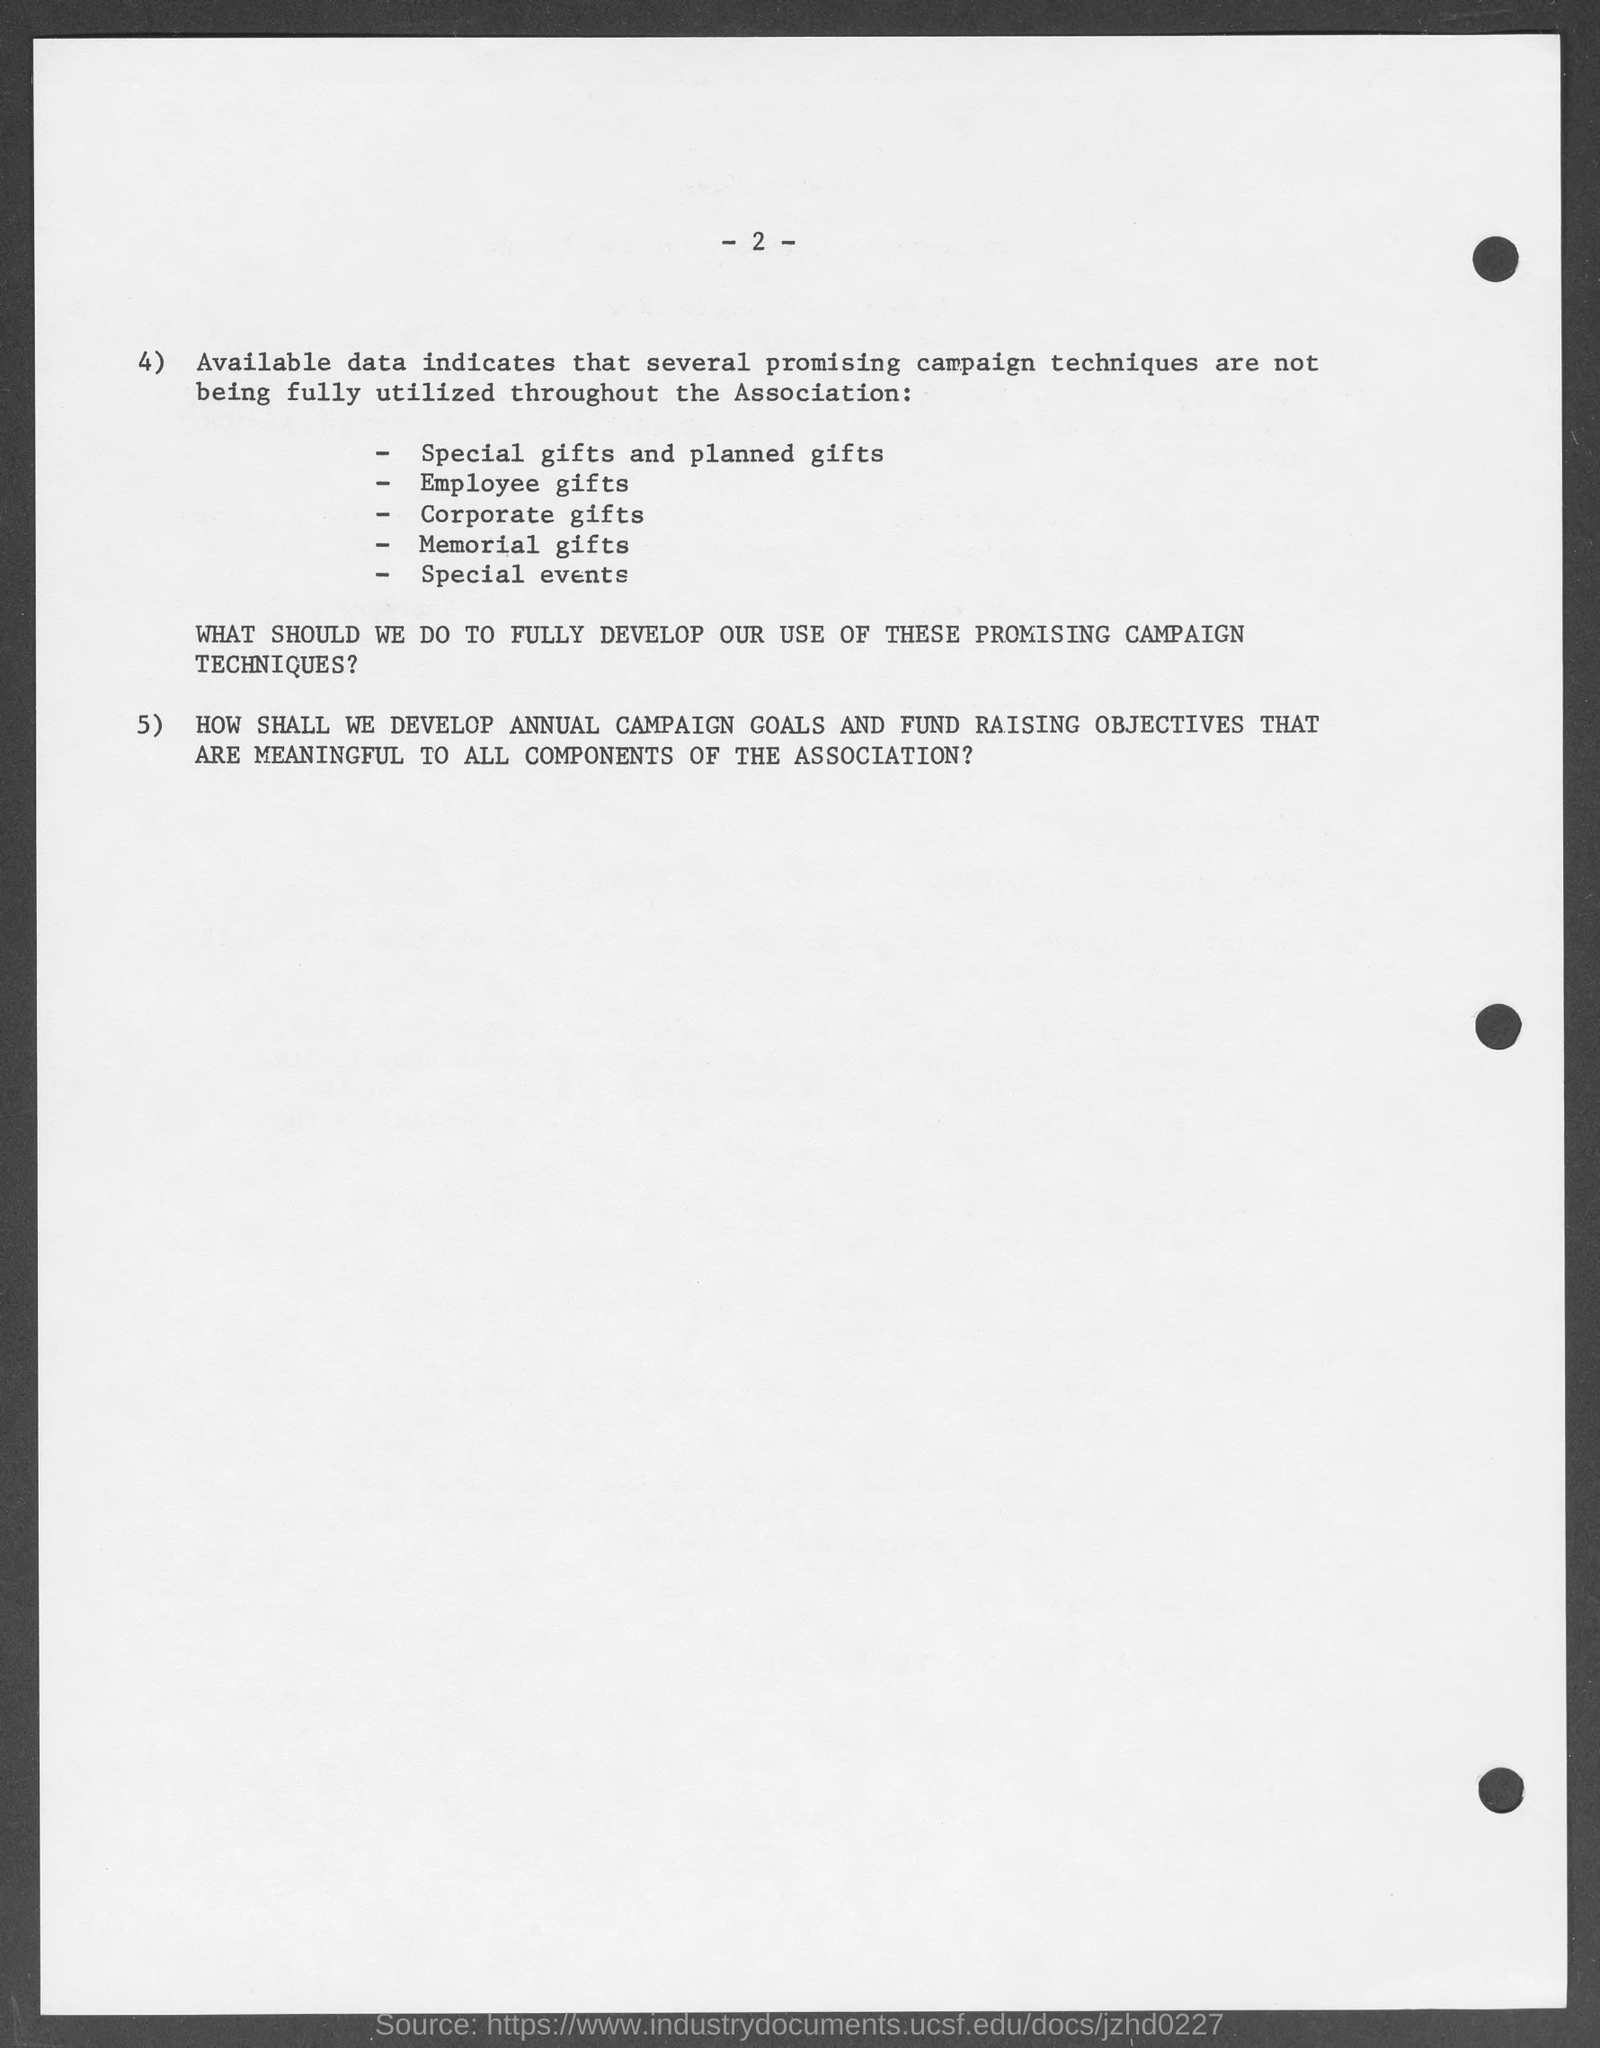Identify some key points in this picture. The page number mentioned in this document is 2. 